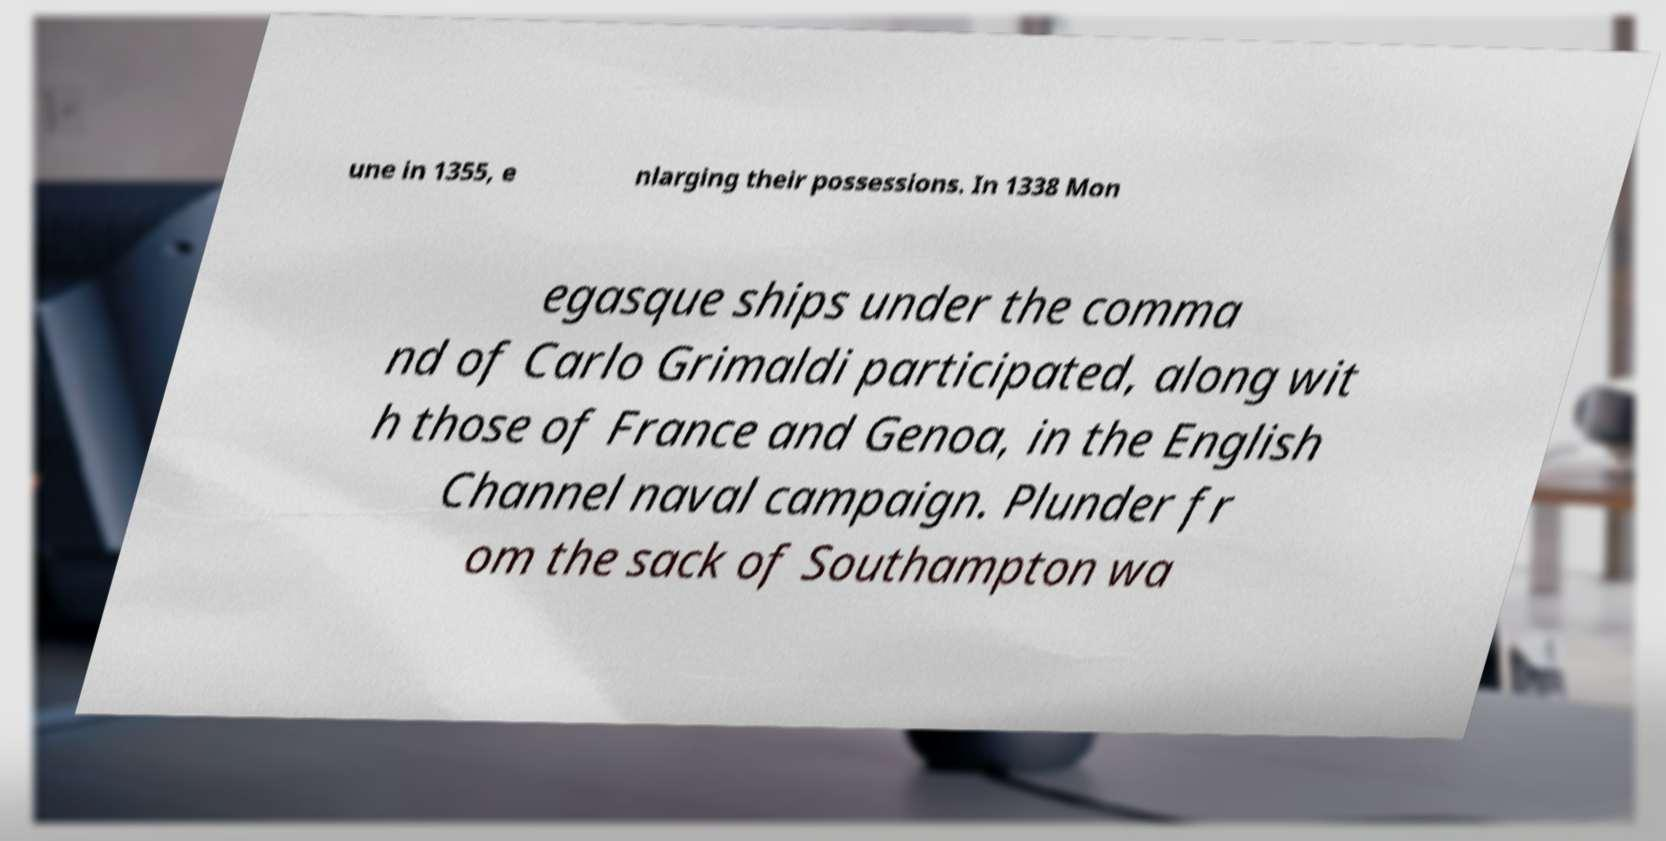Please identify and transcribe the text found in this image. une in 1355, e nlarging their possessions. In 1338 Mon egasque ships under the comma nd of Carlo Grimaldi participated, along wit h those of France and Genoa, in the English Channel naval campaign. Plunder fr om the sack of Southampton wa 